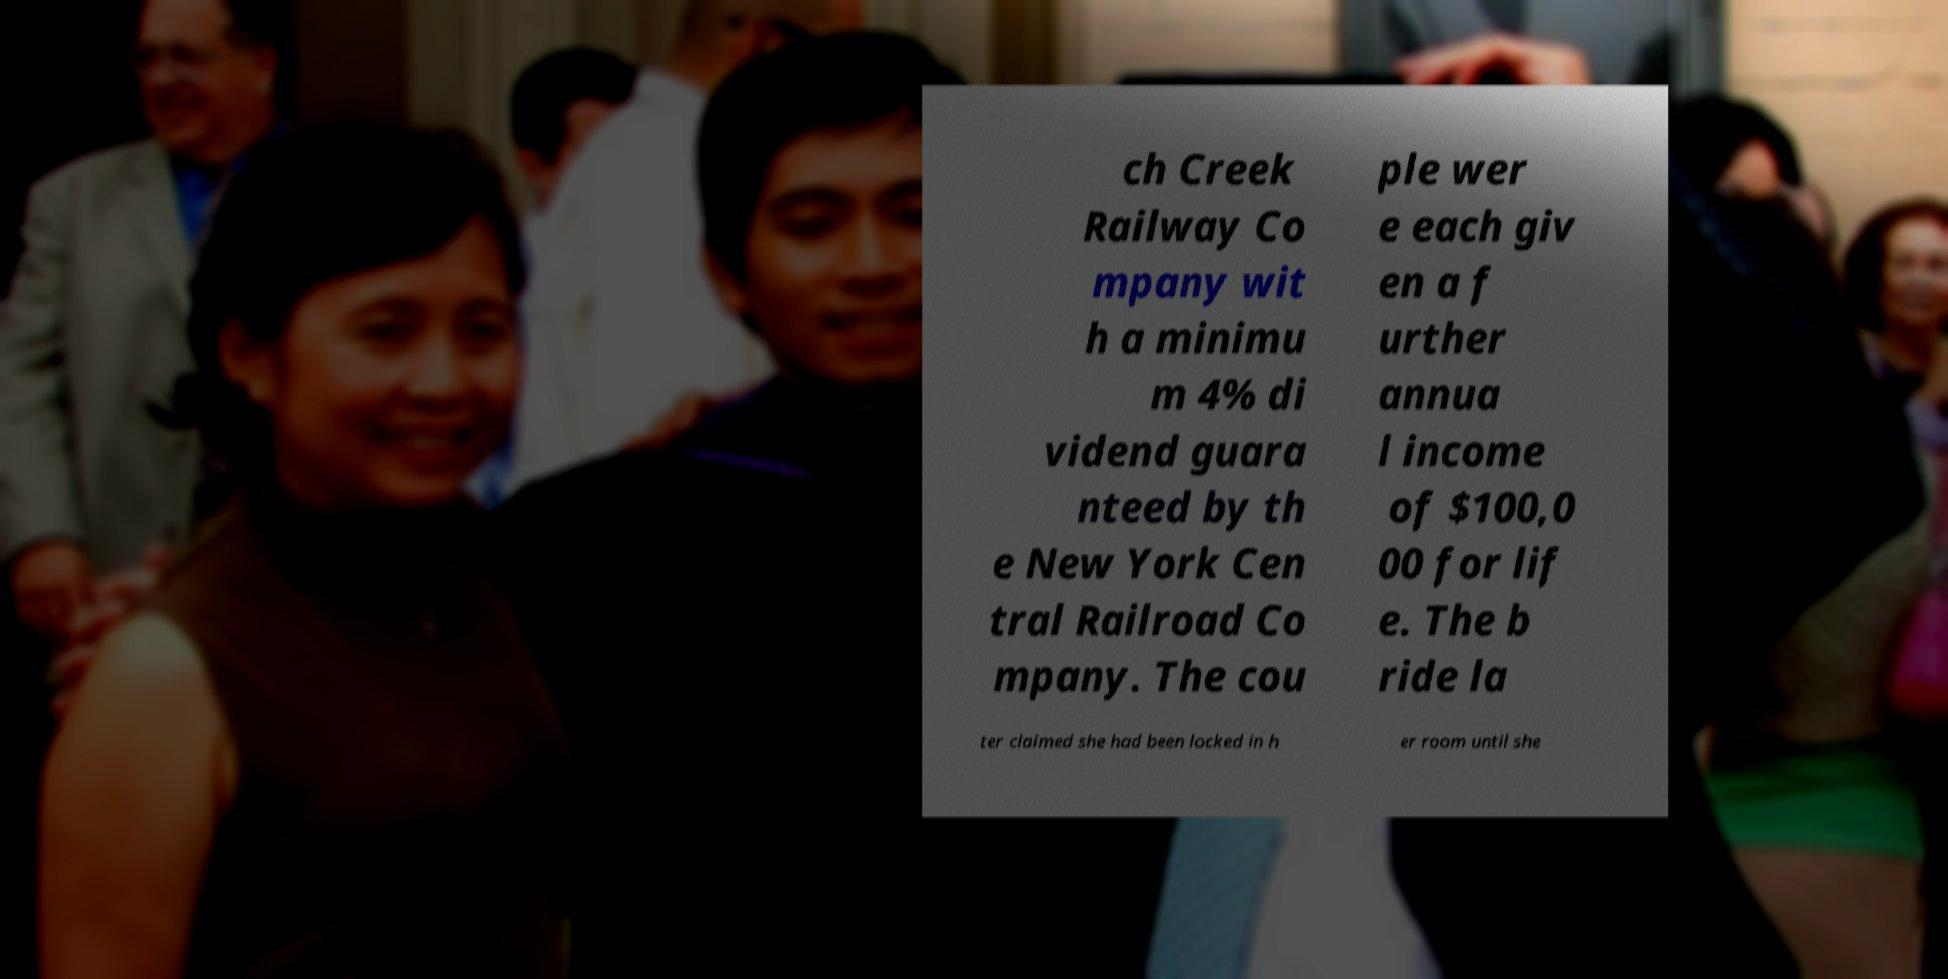I need the written content from this picture converted into text. Can you do that? ch Creek Railway Co mpany wit h a minimu m 4% di vidend guara nteed by th e New York Cen tral Railroad Co mpany. The cou ple wer e each giv en a f urther annua l income of $100,0 00 for lif e. The b ride la ter claimed she had been locked in h er room until she 